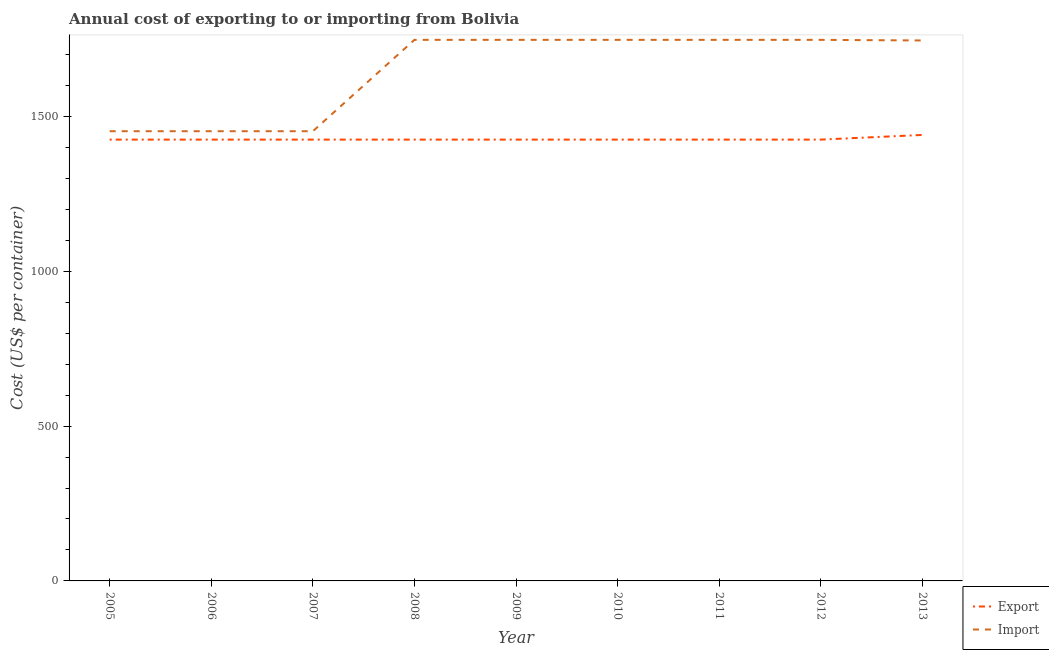How many different coloured lines are there?
Make the answer very short. 2. What is the import cost in 2008?
Give a very brief answer. 1747. Across all years, what is the maximum export cost?
Keep it short and to the point. 1440. Across all years, what is the minimum export cost?
Provide a succinct answer. 1425. In which year was the import cost minimum?
Provide a succinct answer. 2005. What is the total import cost in the graph?
Provide a short and direct response. 1.48e+04. What is the difference between the import cost in 2005 and that in 2007?
Your answer should be compact. 0. What is the difference between the export cost in 2008 and the import cost in 2009?
Offer a terse response. -322. What is the average import cost per year?
Ensure brevity in your answer.  1648.44. In the year 2006, what is the difference between the export cost and import cost?
Provide a short and direct response. -27. What is the ratio of the import cost in 2007 to that in 2011?
Your response must be concise. 0.83. Is the difference between the import cost in 2009 and 2013 greater than the difference between the export cost in 2009 and 2013?
Offer a very short reply. Yes. What is the difference between the highest and the second highest export cost?
Give a very brief answer. 15. What is the difference between the highest and the lowest export cost?
Make the answer very short. 15. Does the import cost monotonically increase over the years?
Your response must be concise. No. Is the export cost strictly less than the import cost over the years?
Offer a very short reply. Yes. What is the difference between two consecutive major ticks on the Y-axis?
Give a very brief answer. 500. Does the graph contain any zero values?
Your answer should be very brief. No. Does the graph contain grids?
Your answer should be very brief. No. What is the title of the graph?
Ensure brevity in your answer.  Annual cost of exporting to or importing from Bolivia. Does "Net savings(excluding particulate emission damage)" appear as one of the legend labels in the graph?
Your answer should be very brief. No. What is the label or title of the X-axis?
Provide a succinct answer. Year. What is the label or title of the Y-axis?
Keep it short and to the point. Cost (US$ per container). What is the Cost (US$ per container) in Export in 2005?
Provide a succinct answer. 1425. What is the Cost (US$ per container) in Import in 2005?
Make the answer very short. 1452. What is the Cost (US$ per container) of Export in 2006?
Ensure brevity in your answer.  1425. What is the Cost (US$ per container) of Import in 2006?
Keep it short and to the point. 1452. What is the Cost (US$ per container) of Export in 2007?
Your answer should be compact. 1425. What is the Cost (US$ per container) of Import in 2007?
Your response must be concise. 1452. What is the Cost (US$ per container) of Export in 2008?
Your answer should be compact. 1425. What is the Cost (US$ per container) in Import in 2008?
Provide a short and direct response. 1747. What is the Cost (US$ per container) of Export in 2009?
Provide a succinct answer. 1425. What is the Cost (US$ per container) of Import in 2009?
Offer a very short reply. 1747. What is the Cost (US$ per container) in Export in 2010?
Your response must be concise. 1425. What is the Cost (US$ per container) of Import in 2010?
Offer a terse response. 1747. What is the Cost (US$ per container) in Export in 2011?
Your response must be concise. 1425. What is the Cost (US$ per container) of Import in 2011?
Offer a very short reply. 1747. What is the Cost (US$ per container) in Export in 2012?
Ensure brevity in your answer.  1425. What is the Cost (US$ per container) of Import in 2012?
Your answer should be very brief. 1747. What is the Cost (US$ per container) in Export in 2013?
Your answer should be compact. 1440. What is the Cost (US$ per container) in Import in 2013?
Your answer should be compact. 1745. Across all years, what is the maximum Cost (US$ per container) in Export?
Offer a very short reply. 1440. Across all years, what is the maximum Cost (US$ per container) in Import?
Offer a terse response. 1747. Across all years, what is the minimum Cost (US$ per container) of Export?
Offer a very short reply. 1425. Across all years, what is the minimum Cost (US$ per container) of Import?
Make the answer very short. 1452. What is the total Cost (US$ per container) of Export in the graph?
Provide a succinct answer. 1.28e+04. What is the total Cost (US$ per container) in Import in the graph?
Provide a succinct answer. 1.48e+04. What is the difference between the Cost (US$ per container) in Export in 2005 and that in 2006?
Your answer should be very brief. 0. What is the difference between the Cost (US$ per container) in Import in 2005 and that in 2006?
Your response must be concise. 0. What is the difference between the Cost (US$ per container) of Export in 2005 and that in 2008?
Provide a short and direct response. 0. What is the difference between the Cost (US$ per container) of Import in 2005 and that in 2008?
Offer a very short reply. -295. What is the difference between the Cost (US$ per container) of Import in 2005 and that in 2009?
Your answer should be very brief. -295. What is the difference between the Cost (US$ per container) of Import in 2005 and that in 2010?
Provide a succinct answer. -295. What is the difference between the Cost (US$ per container) of Export in 2005 and that in 2011?
Your answer should be very brief. 0. What is the difference between the Cost (US$ per container) of Import in 2005 and that in 2011?
Make the answer very short. -295. What is the difference between the Cost (US$ per container) of Import in 2005 and that in 2012?
Your response must be concise. -295. What is the difference between the Cost (US$ per container) in Export in 2005 and that in 2013?
Provide a succinct answer. -15. What is the difference between the Cost (US$ per container) in Import in 2005 and that in 2013?
Offer a terse response. -293. What is the difference between the Cost (US$ per container) in Import in 2006 and that in 2008?
Your answer should be very brief. -295. What is the difference between the Cost (US$ per container) of Export in 2006 and that in 2009?
Offer a terse response. 0. What is the difference between the Cost (US$ per container) of Import in 2006 and that in 2009?
Your response must be concise. -295. What is the difference between the Cost (US$ per container) in Import in 2006 and that in 2010?
Your response must be concise. -295. What is the difference between the Cost (US$ per container) in Export in 2006 and that in 2011?
Offer a terse response. 0. What is the difference between the Cost (US$ per container) in Import in 2006 and that in 2011?
Ensure brevity in your answer.  -295. What is the difference between the Cost (US$ per container) in Export in 2006 and that in 2012?
Offer a very short reply. 0. What is the difference between the Cost (US$ per container) of Import in 2006 and that in 2012?
Make the answer very short. -295. What is the difference between the Cost (US$ per container) in Import in 2006 and that in 2013?
Give a very brief answer. -293. What is the difference between the Cost (US$ per container) in Import in 2007 and that in 2008?
Provide a short and direct response. -295. What is the difference between the Cost (US$ per container) of Import in 2007 and that in 2009?
Keep it short and to the point. -295. What is the difference between the Cost (US$ per container) in Export in 2007 and that in 2010?
Keep it short and to the point. 0. What is the difference between the Cost (US$ per container) of Import in 2007 and that in 2010?
Make the answer very short. -295. What is the difference between the Cost (US$ per container) in Import in 2007 and that in 2011?
Give a very brief answer. -295. What is the difference between the Cost (US$ per container) of Import in 2007 and that in 2012?
Offer a very short reply. -295. What is the difference between the Cost (US$ per container) in Import in 2007 and that in 2013?
Your answer should be compact. -293. What is the difference between the Cost (US$ per container) of Export in 2008 and that in 2009?
Your answer should be very brief. 0. What is the difference between the Cost (US$ per container) in Import in 2008 and that in 2009?
Your answer should be compact. 0. What is the difference between the Cost (US$ per container) in Export in 2008 and that in 2010?
Provide a short and direct response. 0. What is the difference between the Cost (US$ per container) in Import in 2008 and that in 2010?
Keep it short and to the point. 0. What is the difference between the Cost (US$ per container) in Export in 2008 and that in 2011?
Offer a very short reply. 0. What is the difference between the Cost (US$ per container) in Export in 2008 and that in 2012?
Your answer should be very brief. 0. What is the difference between the Cost (US$ per container) in Import in 2008 and that in 2012?
Give a very brief answer. 0. What is the difference between the Cost (US$ per container) in Import in 2008 and that in 2013?
Your response must be concise. 2. What is the difference between the Cost (US$ per container) in Export in 2009 and that in 2010?
Your answer should be very brief. 0. What is the difference between the Cost (US$ per container) of Import in 2009 and that in 2010?
Your answer should be very brief. 0. What is the difference between the Cost (US$ per container) in Import in 2009 and that in 2013?
Ensure brevity in your answer.  2. What is the difference between the Cost (US$ per container) in Export in 2010 and that in 2011?
Give a very brief answer. 0. What is the difference between the Cost (US$ per container) in Export in 2010 and that in 2012?
Keep it short and to the point. 0. What is the difference between the Cost (US$ per container) in Import in 2010 and that in 2012?
Offer a terse response. 0. What is the difference between the Cost (US$ per container) of Import in 2010 and that in 2013?
Your answer should be very brief. 2. What is the difference between the Cost (US$ per container) of Export in 2011 and that in 2012?
Offer a very short reply. 0. What is the difference between the Cost (US$ per container) of Import in 2011 and that in 2013?
Make the answer very short. 2. What is the difference between the Cost (US$ per container) of Export in 2005 and the Cost (US$ per container) of Import in 2007?
Your answer should be very brief. -27. What is the difference between the Cost (US$ per container) in Export in 2005 and the Cost (US$ per container) in Import in 2008?
Offer a very short reply. -322. What is the difference between the Cost (US$ per container) of Export in 2005 and the Cost (US$ per container) of Import in 2009?
Keep it short and to the point. -322. What is the difference between the Cost (US$ per container) in Export in 2005 and the Cost (US$ per container) in Import in 2010?
Offer a very short reply. -322. What is the difference between the Cost (US$ per container) in Export in 2005 and the Cost (US$ per container) in Import in 2011?
Offer a very short reply. -322. What is the difference between the Cost (US$ per container) of Export in 2005 and the Cost (US$ per container) of Import in 2012?
Make the answer very short. -322. What is the difference between the Cost (US$ per container) of Export in 2005 and the Cost (US$ per container) of Import in 2013?
Ensure brevity in your answer.  -320. What is the difference between the Cost (US$ per container) of Export in 2006 and the Cost (US$ per container) of Import in 2007?
Your answer should be very brief. -27. What is the difference between the Cost (US$ per container) in Export in 2006 and the Cost (US$ per container) in Import in 2008?
Provide a succinct answer. -322. What is the difference between the Cost (US$ per container) in Export in 2006 and the Cost (US$ per container) in Import in 2009?
Your response must be concise. -322. What is the difference between the Cost (US$ per container) of Export in 2006 and the Cost (US$ per container) of Import in 2010?
Make the answer very short. -322. What is the difference between the Cost (US$ per container) in Export in 2006 and the Cost (US$ per container) in Import in 2011?
Provide a short and direct response. -322. What is the difference between the Cost (US$ per container) in Export in 2006 and the Cost (US$ per container) in Import in 2012?
Offer a terse response. -322. What is the difference between the Cost (US$ per container) in Export in 2006 and the Cost (US$ per container) in Import in 2013?
Ensure brevity in your answer.  -320. What is the difference between the Cost (US$ per container) of Export in 2007 and the Cost (US$ per container) of Import in 2008?
Your answer should be very brief. -322. What is the difference between the Cost (US$ per container) of Export in 2007 and the Cost (US$ per container) of Import in 2009?
Provide a succinct answer. -322. What is the difference between the Cost (US$ per container) of Export in 2007 and the Cost (US$ per container) of Import in 2010?
Provide a short and direct response. -322. What is the difference between the Cost (US$ per container) in Export in 2007 and the Cost (US$ per container) in Import in 2011?
Keep it short and to the point. -322. What is the difference between the Cost (US$ per container) of Export in 2007 and the Cost (US$ per container) of Import in 2012?
Provide a succinct answer. -322. What is the difference between the Cost (US$ per container) of Export in 2007 and the Cost (US$ per container) of Import in 2013?
Give a very brief answer. -320. What is the difference between the Cost (US$ per container) in Export in 2008 and the Cost (US$ per container) in Import in 2009?
Provide a succinct answer. -322. What is the difference between the Cost (US$ per container) in Export in 2008 and the Cost (US$ per container) in Import in 2010?
Offer a terse response. -322. What is the difference between the Cost (US$ per container) of Export in 2008 and the Cost (US$ per container) of Import in 2011?
Keep it short and to the point. -322. What is the difference between the Cost (US$ per container) in Export in 2008 and the Cost (US$ per container) in Import in 2012?
Ensure brevity in your answer.  -322. What is the difference between the Cost (US$ per container) in Export in 2008 and the Cost (US$ per container) in Import in 2013?
Give a very brief answer. -320. What is the difference between the Cost (US$ per container) of Export in 2009 and the Cost (US$ per container) of Import in 2010?
Your response must be concise. -322. What is the difference between the Cost (US$ per container) in Export in 2009 and the Cost (US$ per container) in Import in 2011?
Your response must be concise. -322. What is the difference between the Cost (US$ per container) of Export in 2009 and the Cost (US$ per container) of Import in 2012?
Provide a succinct answer. -322. What is the difference between the Cost (US$ per container) in Export in 2009 and the Cost (US$ per container) in Import in 2013?
Offer a terse response. -320. What is the difference between the Cost (US$ per container) in Export in 2010 and the Cost (US$ per container) in Import in 2011?
Your response must be concise. -322. What is the difference between the Cost (US$ per container) in Export in 2010 and the Cost (US$ per container) in Import in 2012?
Your response must be concise. -322. What is the difference between the Cost (US$ per container) of Export in 2010 and the Cost (US$ per container) of Import in 2013?
Provide a short and direct response. -320. What is the difference between the Cost (US$ per container) in Export in 2011 and the Cost (US$ per container) in Import in 2012?
Ensure brevity in your answer.  -322. What is the difference between the Cost (US$ per container) in Export in 2011 and the Cost (US$ per container) in Import in 2013?
Give a very brief answer. -320. What is the difference between the Cost (US$ per container) in Export in 2012 and the Cost (US$ per container) in Import in 2013?
Provide a succinct answer. -320. What is the average Cost (US$ per container) in Export per year?
Keep it short and to the point. 1426.67. What is the average Cost (US$ per container) of Import per year?
Your answer should be very brief. 1648.44. In the year 2007, what is the difference between the Cost (US$ per container) of Export and Cost (US$ per container) of Import?
Your answer should be compact. -27. In the year 2008, what is the difference between the Cost (US$ per container) in Export and Cost (US$ per container) in Import?
Offer a very short reply. -322. In the year 2009, what is the difference between the Cost (US$ per container) in Export and Cost (US$ per container) in Import?
Keep it short and to the point. -322. In the year 2010, what is the difference between the Cost (US$ per container) of Export and Cost (US$ per container) of Import?
Give a very brief answer. -322. In the year 2011, what is the difference between the Cost (US$ per container) in Export and Cost (US$ per container) in Import?
Keep it short and to the point. -322. In the year 2012, what is the difference between the Cost (US$ per container) in Export and Cost (US$ per container) in Import?
Provide a short and direct response. -322. In the year 2013, what is the difference between the Cost (US$ per container) in Export and Cost (US$ per container) in Import?
Make the answer very short. -305. What is the ratio of the Cost (US$ per container) in Import in 2005 to that in 2006?
Your answer should be compact. 1. What is the ratio of the Cost (US$ per container) of Import in 2005 to that in 2007?
Provide a short and direct response. 1. What is the ratio of the Cost (US$ per container) in Import in 2005 to that in 2008?
Your answer should be very brief. 0.83. What is the ratio of the Cost (US$ per container) of Import in 2005 to that in 2009?
Your answer should be very brief. 0.83. What is the ratio of the Cost (US$ per container) in Import in 2005 to that in 2010?
Keep it short and to the point. 0.83. What is the ratio of the Cost (US$ per container) of Export in 2005 to that in 2011?
Your answer should be compact. 1. What is the ratio of the Cost (US$ per container) in Import in 2005 to that in 2011?
Provide a succinct answer. 0.83. What is the ratio of the Cost (US$ per container) of Export in 2005 to that in 2012?
Make the answer very short. 1. What is the ratio of the Cost (US$ per container) of Import in 2005 to that in 2012?
Your answer should be very brief. 0.83. What is the ratio of the Cost (US$ per container) in Export in 2005 to that in 2013?
Your answer should be compact. 0.99. What is the ratio of the Cost (US$ per container) of Import in 2005 to that in 2013?
Keep it short and to the point. 0.83. What is the ratio of the Cost (US$ per container) of Export in 2006 to that in 2007?
Your answer should be compact. 1. What is the ratio of the Cost (US$ per container) in Import in 2006 to that in 2007?
Your response must be concise. 1. What is the ratio of the Cost (US$ per container) of Import in 2006 to that in 2008?
Give a very brief answer. 0.83. What is the ratio of the Cost (US$ per container) in Import in 2006 to that in 2009?
Your response must be concise. 0.83. What is the ratio of the Cost (US$ per container) of Import in 2006 to that in 2010?
Make the answer very short. 0.83. What is the ratio of the Cost (US$ per container) of Import in 2006 to that in 2011?
Your answer should be compact. 0.83. What is the ratio of the Cost (US$ per container) in Import in 2006 to that in 2012?
Ensure brevity in your answer.  0.83. What is the ratio of the Cost (US$ per container) in Import in 2006 to that in 2013?
Keep it short and to the point. 0.83. What is the ratio of the Cost (US$ per container) in Export in 2007 to that in 2008?
Make the answer very short. 1. What is the ratio of the Cost (US$ per container) of Import in 2007 to that in 2008?
Offer a terse response. 0.83. What is the ratio of the Cost (US$ per container) of Export in 2007 to that in 2009?
Keep it short and to the point. 1. What is the ratio of the Cost (US$ per container) of Import in 2007 to that in 2009?
Keep it short and to the point. 0.83. What is the ratio of the Cost (US$ per container) in Import in 2007 to that in 2010?
Your answer should be compact. 0.83. What is the ratio of the Cost (US$ per container) in Export in 2007 to that in 2011?
Offer a very short reply. 1. What is the ratio of the Cost (US$ per container) in Import in 2007 to that in 2011?
Your response must be concise. 0.83. What is the ratio of the Cost (US$ per container) of Export in 2007 to that in 2012?
Your answer should be very brief. 1. What is the ratio of the Cost (US$ per container) in Import in 2007 to that in 2012?
Provide a succinct answer. 0.83. What is the ratio of the Cost (US$ per container) in Export in 2007 to that in 2013?
Keep it short and to the point. 0.99. What is the ratio of the Cost (US$ per container) of Import in 2007 to that in 2013?
Your answer should be compact. 0.83. What is the ratio of the Cost (US$ per container) in Export in 2008 to that in 2009?
Provide a short and direct response. 1. What is the ratio of the Cost (US$ per container) in Import in 2008 to that in 2011?
Your answer should be compact. 1. What is the ratio of the Cost (US$ per container) of Import in 2008 to that in 2012?
Offer a very short reply. 1. What is the ratio of the Cost (US$ per container) of Export in 2008 to that in 2013?
Offer a terse response. 0.99. What is the ratio of the Cost (US$ per container) of Import in 2008 to that in 2013?
Make the answer very short. 1. What is the ratio of the Cost (US$ per container) in Export in 2009 to that in 2010?
Ensure brevity in your answer.  1. What is the ratio of the Cost (US$ per container) in Import in 2009 to that in 2010?
Offer a terse response. 1. What is the ratio of the Cost (US$ per container) in Export in 2009 to that in 2011?
Provide a short and direct response. 1. What is the ratio of the Cost (US$ per container) of Import in 2009 to that in 2012?
Give a very brief answer. 1. What is the ratio of the Cost (US$ per container) of Export in 2009 to that in 2013?
Make the answer very short. 0.99. What is the ratio of the Cost (US$ per container) in Import in 2009 to that in 2013?
Provide a short and direct response. 1. What is the ratio of the Cost (US$ per container) of Export in 2010 to that in 2011?
Your answer should be very brief. 1. What is the ratio of the Cost (US$ per container) in Import in 2010 to that in 2011?
Your answer should be very brief. 1. What is the ratio of the Cost (US$ per container) of Export in 2010 to that in 2012?
Your response must be concise. 1. What is the ratio of the Cost (US$ per container) in Import in 2010 to that in 2012?
Make the answer very short. 1. What is the ratio of the Cost (US$ per container) in Export in 2010 to that in 2013?
Your answer should be compact. 0.99. What is the ratio of the Cost (US$ per container) in Export in 2011 to that in 2013?
Offer a very short reply. 0.99. What is the difference between the highest and the second highest Cost (US$ per container) of Export?
Your answer should be very brief. 15. What is the difference between the highest and the second highest Cost (US$ per container) of Import?
Offer a terse response. 0. What is the difference between the highest and the lowest Cost (US$ per container) of Import?
Provide a short and direct response. 295. 